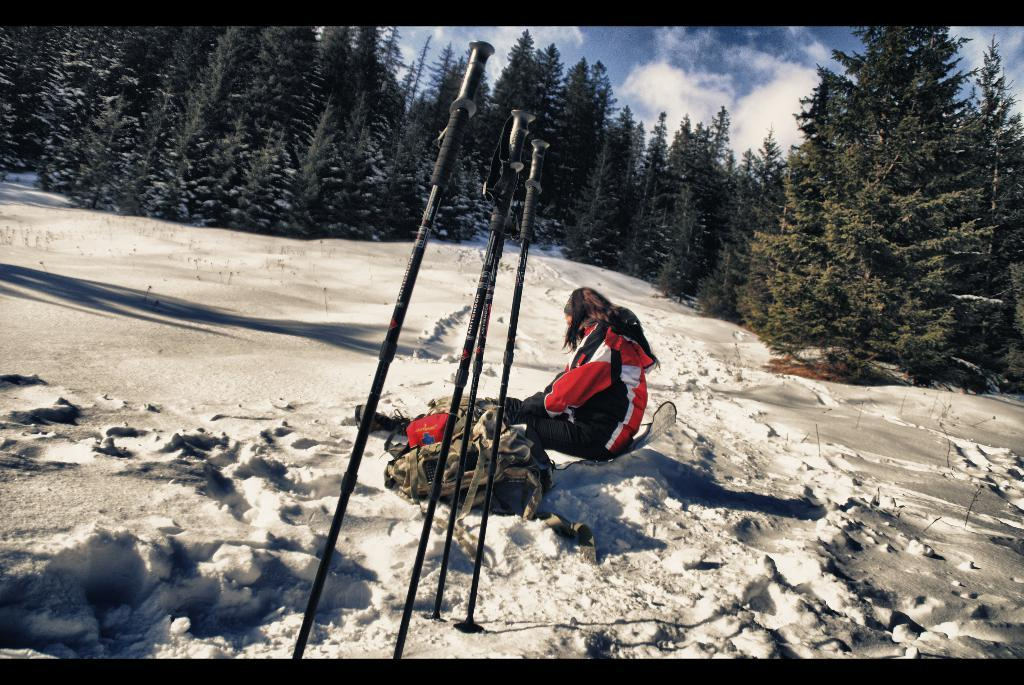What objects can be seen in the image? There are sticks and a bag visible in the image. What is the person in the image doing? The person is sitting on snow in the image. What can be seen in the background of the image? There are trees and the sky visible in the background of the image. What is the condition of the sky in the image? Clouds are present in the sky in the image. What type of machine is being operated by the governor in the image? There is no governor or machine present in the image. How does the person in the image plan to join the group of people in the distance? There is no group of people in the distance in the image, and the person is not shown attempting to join any group. 